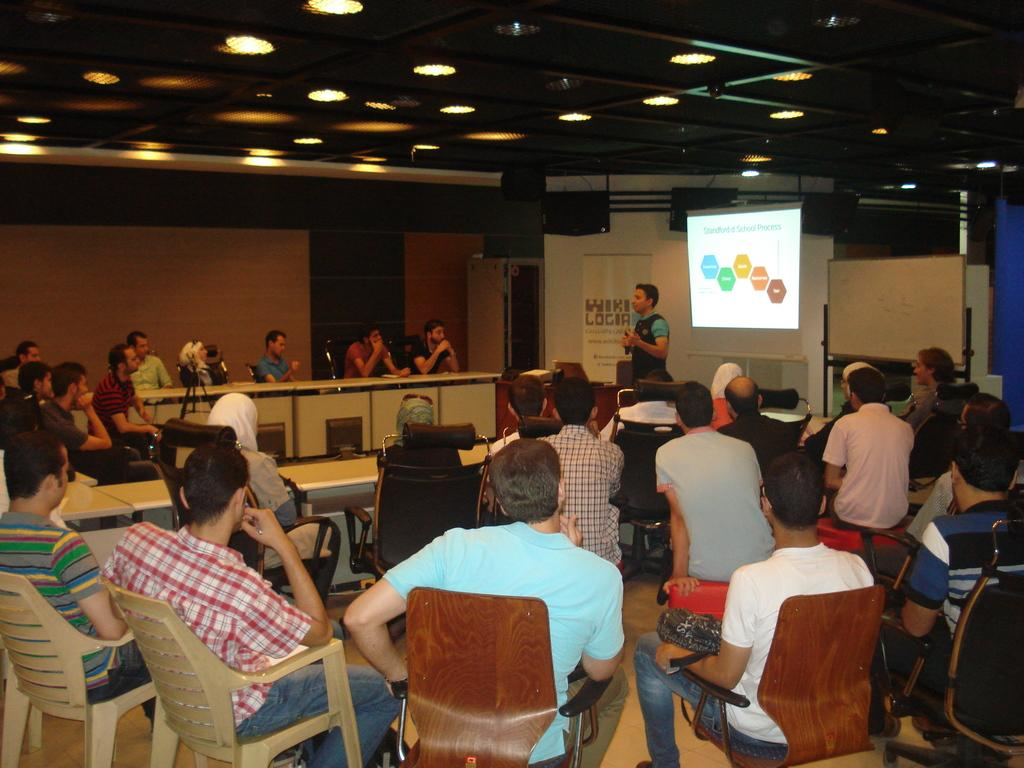What is the main subject of the image? The main subject of the image is a guy. What is the guy doing in the image? The guy is explaining something in the image. What is behind the guy in the image? There is a projector screen behind the guy. Who else is present in the image? There are people sitting and listening in the image. Where was the image taken? The image was taken inside a conference hall. What type of spoon can be seen on the projector screen in the image? There is no spoon present on the projector screen in the image. What kind of stamp is visible on the guy's shirt in the image? There is no stamp visible on the guy's shirt in the image. 